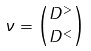<formula> <loc_0><loc_0><loc_500><loc_500>\nu = { D ^ { > } \choose D ^ { < } }</formula> 